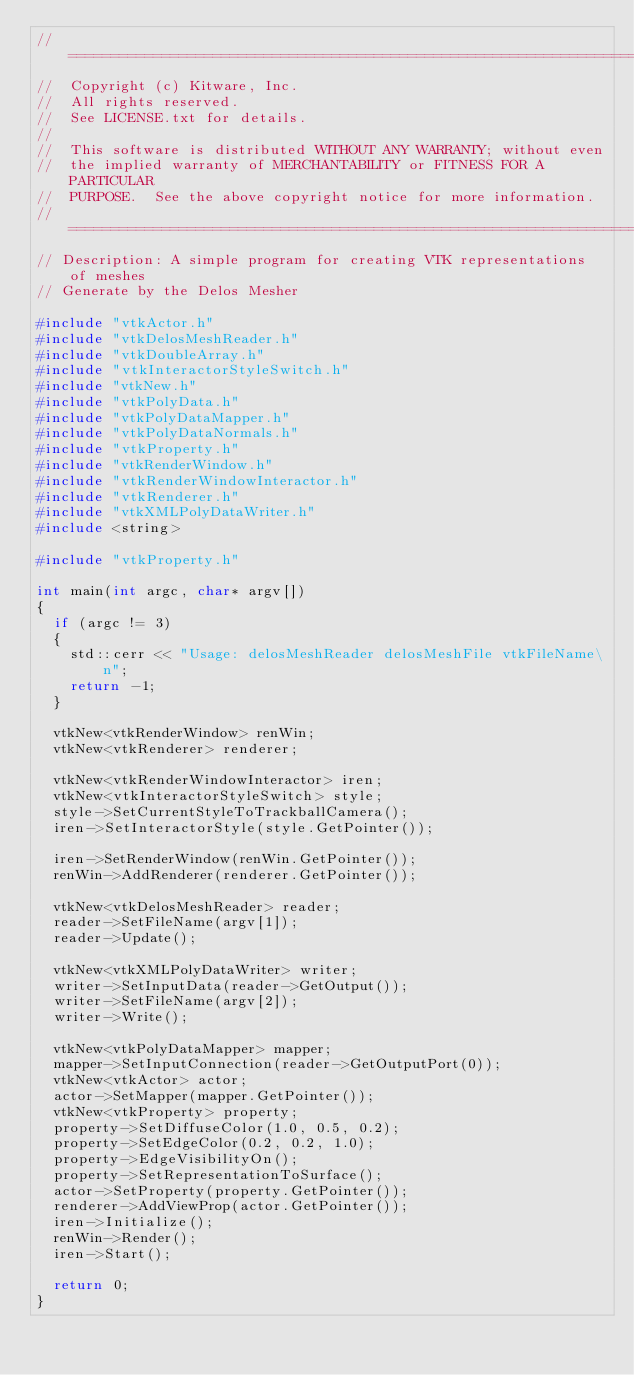<code> <loc_0><loc_0><loc_500><loc_500><_C++_>//=========================================================================
//  Copyright (c) Kitware, Inc.
//  All rights reserved.
//  See LICENSE.txt for details.
//
//  This software is distributed WITHOUT ANY WARRANTY; without even
//  the implied warranty of MERCHANTABILITY or FITNESS FOR A PARTICULAR
//  PURPOSE.  See the above copyright notice for more information.
//=========================================================================
// Description: A simple program for creating VTK representations of meshes
// Generate by the Delos Mesher

#include "vtkActor.h"
#include "vtkDelosMeshReader.h"
#include "vtkDoubleArray.h"
#include "vtkInteractorStyleSwitch.h"
#include "vtkNew.h"
#include "vtkPolyData.h"
#include "vtkPolyDataMapper.h"
#include "vtkPolyDataNormals.h"
#include "vtkProperty.h"
#include "vtkRenderWindow.h"
#include "vtkRenderWindowInteractor.h"
#include "vtkRenderer.h"
#include "vtkXMLPolyDataWriter.h"
#include <string>

#include "vtkProperty.h"

int main(int argc, char* argv[])
{
  if (argc != 3)
  {
    std::cerr << "Usage: delosMeshReader delosMeshFile vtkFileName\n";
    return -1;
  }

  vtkNew<vtkRenderWindow> renWin;
  vtkNew<vtkRenderer> renderer;

  vtkNew<vtkRenderWindowInteractor> iren;
  vtkNew<vtkInteractorStyleSwitch> style;
  style->SetCurrentStyleToTrackballCamera();
  iren->SetInteractorStyle(style.GetPointer());

  iren->SetRenderWindow(renWin.GetPointer());
  renWin->AddRenderer(renderer.GetPointer());

  vtkNew<vtkDelosMeshReader> reader;
  reader->SetFileName(argv[1]);
  reader->Update();

  vtkNew<vtkXMLPolyDataWriter> writer;
  writer->SetInputData(reader->GetOutput());
  writer->SetFileName(argv[2]);
  writer->Write();

  vtkNew<vtkPolyDataMapper> mapper;
  mapper->SetInputConnection(reader->GetOutputPort(0));
  vtkNew<vtkActor> actor;
  actor->SetMapper(mapper.GetPointer());
  vtkNew<vtkProperty> property;
  property->SetDiffuseColor(1.0, 0.5, 0.2);
  property->SetEdgeColor(0.2, 0.2, 1.0);
  property->EdgeVisibilityOn();
  property->SetRepresentationToSurface();
  actor->SetProperty(property.GetPointer());
  renderer->AddViewProp(actor.GetPointer());
  iren->Initialize();
  renWin->Render();
  iren->Start();

  return 0;
}
</code> 